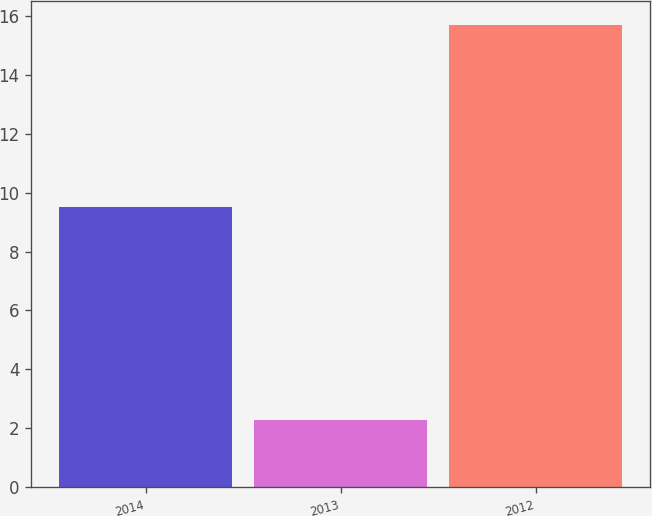<chart> <loc_0><loc_0><loc_500><loc_500><bar_chart><fcel>2014<fcel>2013<fcel>2012<nl><fcel>9.5<fcel>2.3<fcel>15.7<nl></chart> 